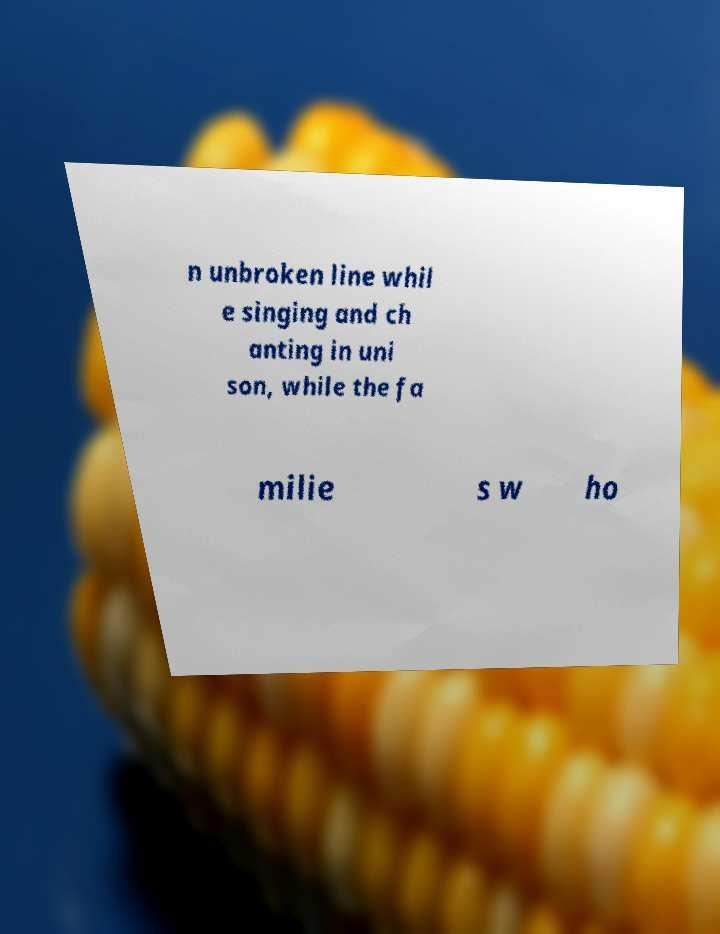Please read and relay the text visible in this image. What does it say? n unbroken line whil e singing and ch anting in uni son, while the fa milie s w ho 